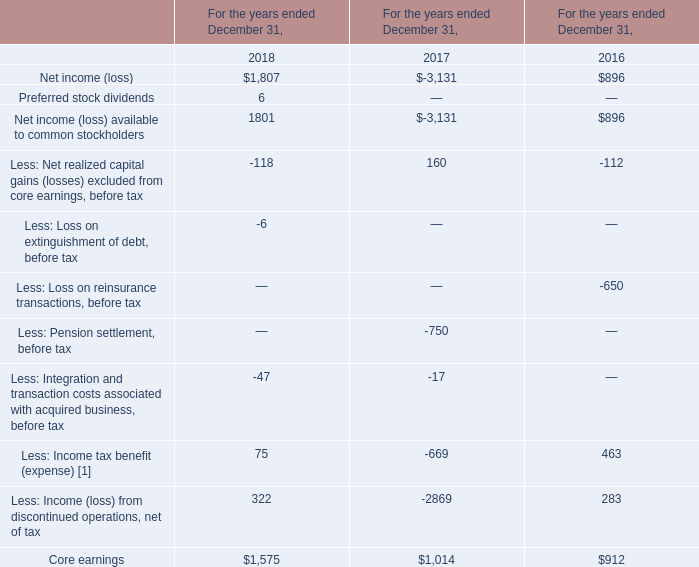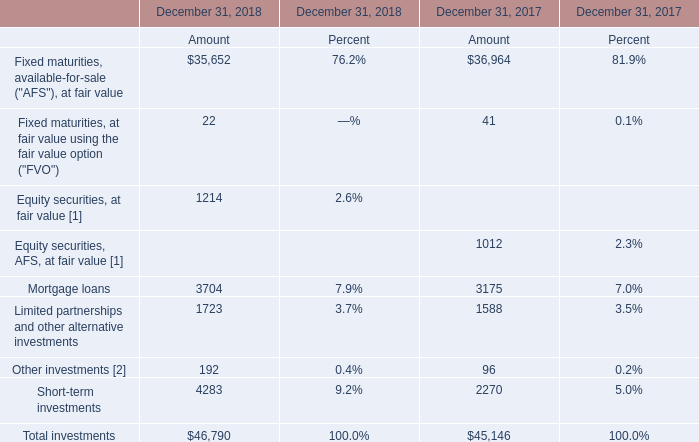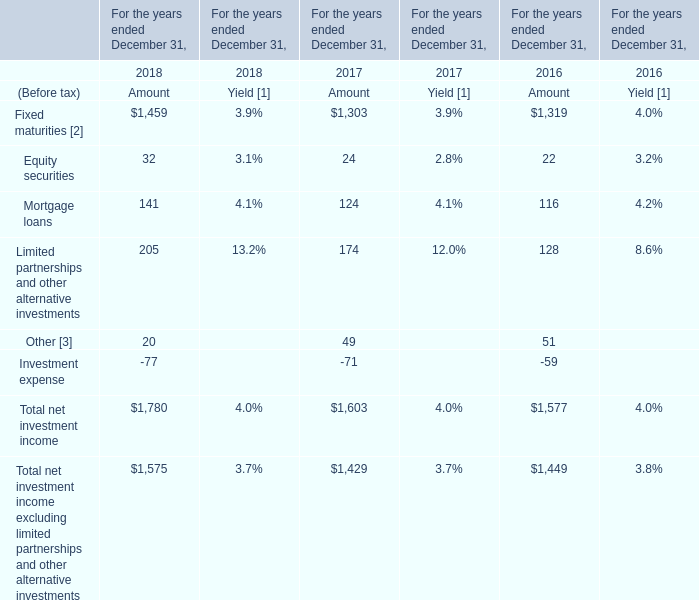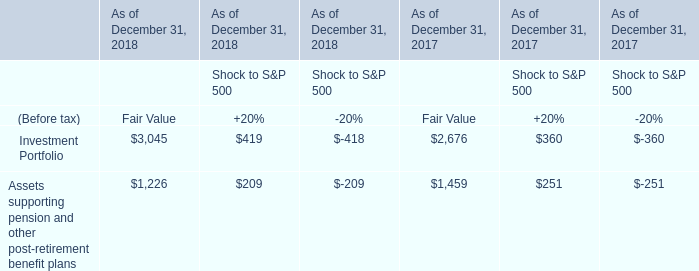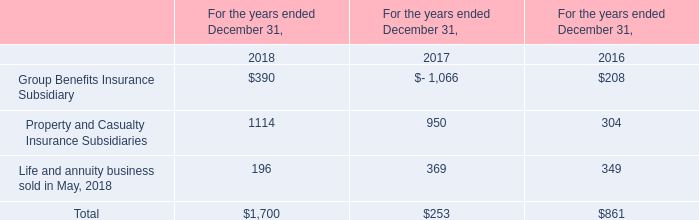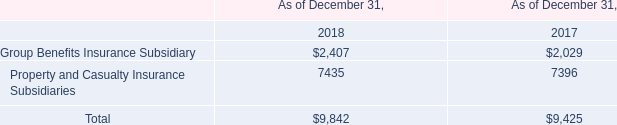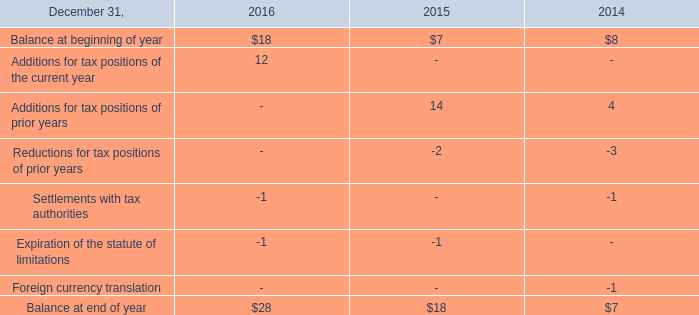What is the percentage of Mortgage loans in relation to the total in 2018? ? 
Computations: (3704 / 46790)
Answer: 0.07916. 